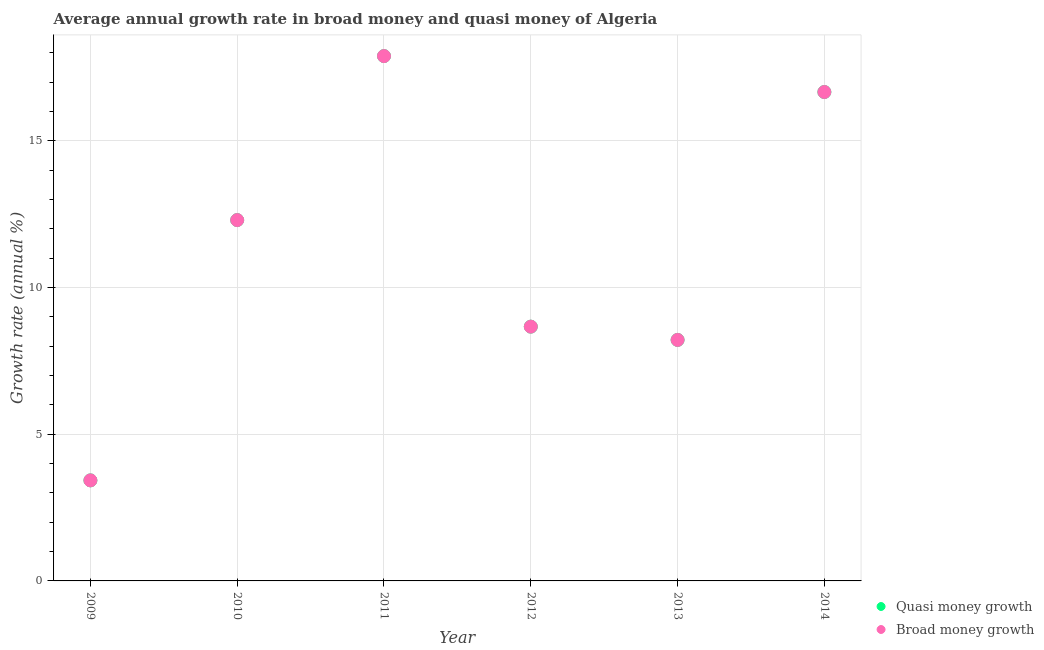Is the number of dotlines equal to the number of legend labels?
Provide a succinct answer. Yes. What is the annual growth rate in quasi money in 2014?
Your answer should be compact. 16.67. Across all years, what is the maximum annual growth rate in broad money?
Your response must be concise. 17.89. Across all years, what is the minimum annual growth rate in broad money?
Offer a terse response. 3.43. What is the total annual growth rate in broad money in the graph?
Keep it short and to the point. 67.17. What is the difference between the annual growth rate in quasi money in 2010 and that in 2012?
Your answer should be compact. 3.63. What is the difference between the annual growth rate in quasi money in 2011 and the annual growth rate in broad money in 2014?
Give a very brief answer. 1.22. What is the average annual growth rate in broad money per year?
Give a very brief answer. 11.19. In how many years, is the annual growth rate in broad money greater than 9 %?
Keep it short and to the point. 3. What is the ratio of the annual growth rate in quasi money in 2012 to that in 2013?
Your answer should be compact. 1.06. What is the difference between the highest and the second highest annual growth rate in quasi money?
Offer a terse response. 1.22. What is the difference between the highest and the lowest annual growth rate in broad money?
Provide a short and direct response. 14.46. Does the annual growth rate in broad money monotonically increase over the years?
Make the answer very short. No. How many dotlines are there?
Offer a terse response. 2. How many years are there in the graph?
Give a very brief answer. 6. What is the difference between two consecutive major ticks on the Y-axis?
Your answer should be compact. 5. Are the values on the major ticks of Y-axis written in scientific E-notation?
Provide a short and direct response. No. Does the graph contain grids?
Offer a terse response. Yes. Where does the legend appear in the graph?
Give a very brief answer. Bottom right. How many legend labels are there?
Offer a very short reply. 2. How are the legend labels stacked?
Provide a short and direct response. Vertical. What is the title of the graph?
Keep it short and to the point. Average annual growth rate in broad money and quasi money of Algeria. What is the label or title of the Y-axis?
Your answer should be very brief. Growth rate (annual %). What is the Growth rate (annual %) of Quasi money growth in 2009?
Make the answer very short. 3.43. What is the Growth rate (annual %) of Broad money growth in 2009?
Make the answer very short. 3.43. What is the Growth rate (annual %) in Quasi money growth in 2010?
Offer a very short reply. 12.3. What is the Growth rate (annual %) in Broad money growth in 2010?
Your response must be concise. 12.3. What is the Growth rate (annual %) of Quasi money growth in 2011?
Keep it short and to the point. 17.89. What is the Growth rate (annual %) of Broad money growth in 2011?
Offer a very short reply. 17.89. What is the Growth rate (annual %) in Quasi money growth in 2012?
Your answer should be compact. 8.67. What is the Growth rate (annual %) in Broad money growth in 2012?
Make the answer very short. 8.67. What is the Growth rate (annual %) in Quasi money growth in 2013?
Your answer should be very brief. 8.22. What is the Growth rate (annual %) of Broad money growth in 2013?
Your answer should be compact. 8.22. What is the Growth rate (annual %) in Quasi money growth in 2014?
Your answer should be compact. 16.67. What is the Growth rate (annual %) in Broad money growth in 2014?
Keep it short and to the point. 16.67. Across all years, what is the maximum Growth rate (annual %) in Quasi money growth?
Make the answer very short. 17.89. Across all years, what is the maximum Growth rate (annual %) of Broad money growth?
Offer a terse response. 17.89. Across all years, what is the minimum Growth rate (annual %) of Quasi money growth?
Offer a terse response. 3.43. Across all years, what is the minimum Growth rate (annual %) in Broad money growth?
Offer a very short reply. 3.43. What is the total Growth rate (annual %) in Quasi money growth in the graph?
Keep it short and to the point. 67.17. What is the total Growth rate (annual %) of Broad money growth in the graph?
Ensure brevity in your answer.  67.17. What is the difference between the Growth rate (annual %) in Quasi money growth in 2009 and that in 2010?
Your answer should be very brief. -8.87. What is the difference between the Growth rate (annual %) in Broad money growth in 2009 and that in 2010?
Offer a very short reply. -8.87. What is the difference between the Growth rate (annual %) of Quasi money growth in 2009 and that in 2011?
Your response must be concise. -14.46. What is the difference between the Growth rate (annual %) in Broad money growth in 2009 and that in 2011?
Make the answer very short. -14.46. What is the difference between the Growth rate (annual %) in Quasi money growth in 2009 and that in 2012?
Ensure brevity in your answer.  -5.24. What is the difference between the Growth rate (annual %) of Broad money growth in 2009 and that in 2012?
Offer a terse response. -5.24. What is the difference between the Growth rate (annual %) in Quasi money growth in 2009 and that in 2013?
Offer a very short reply. -4.79. What is the difference between the Growth rate (annual %) in Broad money growth in 2009 and that in 2013?
Offer a terse response. -4.79. What is the difference between the Growth rate (annual %) in Quasi money growth in 2009 and that in 2014?
Provide a short and direct response. -13.24. What is the difference between the Growth rate (annual %) in Broad money growth in 2009 and that in 2014?
Your response must be concise. -13.24. What is the difference between the Growth rate (annual %) in Quasi money growth in 2010 and that in 2011?
Your response must be concise. -5.59. What is the difference between the Growth rate (annual %) in Broad money growth in 2010 and that in 2011?
Make the answer very short. -5.59. What is the difference between the Growth rate (annual %) of Quasi money growth in 2010 and that in 2012?
Keep it short and to the point. 3.63. What is the difference between the Growth rate (annual %) in Broad money growth in 2010 and that in 2012?
Provide a short and direct response. 3.63. What is the difference between the Growth rate (annual %) in Quasi money growth in 2010 and that in 2013?
Provide a succinct answer. 4.09. What is the difference between the Growth rate (annual %) in Broad money growth in 2010 and that in 2013?
Ensure brevity in your answer.  4.09. What is the difference between the Growth rate (annual %) in Quasi money growth in 2010 and that in 2014?
Your answer should be very brief. -4.37. What is the difference between the Growth rate (annual %) of Broad money growth in 2010 and that in 2014?
Ensure brevity in your answer.  -4.37. What is the difference between the Growth rate (annual %) in Quasi money growth in 2011 and that in 2012?
Offer a very short reply. 9.22. What is the difference between the Growth rate (annual %) in Broad money growth in 2011 and that in 2012?
Keep it short and to the point. 9.22. What is the difference between the Growth rate (annual %) of Quasi money growth in 2011 and that in 2013?
Make the answer very short. 9.68. What is the difference between the Growth rate (annual %) of Broad money growth in 2011 and that in 2013?
Keep it short and to the point. 9.68. What is the difference between the Growth rate (annual %) in Quasi money growth in 2011 and that in 2014?
Your response must be concise. 1.22. What is the difference between the Growth rate (annual %) in Broad money growth in 2011 and that in 2014?
Give a very brief answer. 1.22. What is the difference between the Growth rate (annual %) in Quasi money growth in 2012 and that in 2013?
Your answer should be compact. 0.45. What is the difference between the Growth rate (annual %) of Broad money growth in 2012 and that in 2013?
Give a very brief answer. 0.45. What is the difference between the Growth rate (annual %) in Quasi money growth in 2012 and that in 2014?
Provide a succinct answer. -8. What is the difference between the Growth rate (annual %) of Broad money growth in 2012 and that in 2014?
Keep it short and to the point. -8. What is the difference between the Growth rate (annual %) in Quasi money growth in 2013 and that in 2014?
Provide a short and direct response. -8.45. What is the difference between the Growth rate (annual %) in Broad money growth in 2013 and that in 2014?
Provide a short and direct response. -8.45. What is the difference between the Growth rate (annual %) of Quasi money growth in 2009 and the Growth rate (annual %) of Broad money growth in 2010?
Make the answer very short. -8.87. What is the difference between the Growth rate (annual %) of Quasi money growth in 2009 and the Growth rate (annual %) of Broad money growth in 2011?
Your answer should be compact. -14.46. What is the difference between the Growth rate (annual %) in Quasi money growth in 2009 and the Growth rate (annual %) in Broad money growth in 2012?
Offer a very short reply. -5.24. What is the difference between the Growth rate (annual %) of Quasi money growth in 2009 and the Growth rate (annual %) of Broad money growth in 2013?
Provide a succinct answer. -4.79. What is the difference between the Growth rate (annual %) of Quasi money growth in 2009 and the Growth rate (annual %) of Broad money growth in 2014?
Offer a very short reply. -13.24. What is the difference between the Growth rate (annual %) of Quasi money growth in 2010 and the Growth rate (annual %) of Broad money growth in 2011?
Provide a short and direct response. -5.59. What is the difference between the Growth rate (annual %) of Quasi money growth in 2010 and the Growth rate (annual %) of Broad money growth in 2012?
Provide a short and direct response. 3.63. What is the difference between the Growth rate (annual %) in Quasi money growth in 2010 and the Growth rate (annual %) in Broad money growth in 2013?
Your answer should be compact. 4.09. What is the difference between the Growth rate (annual %) in Quasi money growth in 2010 and the Growth rate (annual %) in Broad money growth in 2014?
Your answer should be compact. -4.37. What is the difference between the Growth rate (annual %) of Quasi money growth in 2011 and the Growth rate (annual %) of Broad money growth in 2012?
Offer a very short reply. 9.22. What is the difference between the Growth rate (annual %) in Quasi money growth in 2011 and the Growth rate (annual %) in Broad money growth in 2013?
Keep it short and to the point. 9.68. What is the difference between the Growth rate (annual %) of Quasi money growth in 2011 and the Growth rate (annual %) of Broad money growth in 2014?
Your answer should be very brief. 1.22. What is the difference between the Growth rate (annual %) of Quasi money growth in 2012 and the Growth rate (annual %) of Broad money growth in 2013?
Provide a short and direct response. 0.45. What is the difference between the Growth rate (annual %) in Quasi money growth in 2012 and the Growth rate (annual %) in Broad money growth in 2014?
Your answer should be compact. -8. What is the difference between the Growth rate (annual %) of Quasi money growth in 2013 and the Growth rate (annual %) of Broad money growth in 2014?
Your answer should be very brief. -8.45. What is the average Growth rate (annual %) of Quasi money growth per year?
Your answer should be very brief. 11.19. What is the average Growth rate (annual %) of Broad money growth per year?
Your response must be concise. 11.19. In the year 2010, what is the difference between the Growth rate (annual %) of Quasi money growth and Growth rate (annual %) of Broad money growth?
Provide a short and direct response. 0. In the year 2012, what is the difference between the Growth rate (annual %) of Quasi money growth and Growth rate (annual %) of Broad money growth?
Your response must be concise. 0. In the year 2013, what is the difference between the Growth rate (annual %) of Quasi money growth and Growth rate (annual %) of Broad money growth?
Ensure brevity in your answer.  0. What is the ratio of the Growth rate (annual %) in Quasi money growth in 2009 to that in 2010?
Offer a terse response. 0.28. What is the ratio of the Growth rate (annual %) in Broad money growth in 2009 to that in 2010?
Ensure brevity in your answer.  0.28. What is the ratio of the Growth rate (annual %) of Quasi money growth in 2009 to that in 2011?
Provide a short and direct response. 0.19. What is the ratio of the Growth rate (annual %) in Broad money growth in 2009 to that in 2011?
Your response must be concise. 0.19. What is the ratio of the Growth rate (annual %) of Quasi money growth in 2009 to that in 2012?
Provide a short and direct response. 0.4. What is the ratio of the Growth rate (annual %) of Broad money growth in 2009 to that in 2012?
Offer a terse response. 0.4. What is the ratio of the Growth rate (annual %) in Quasi money growth in 2009 to that in 2013?
Ensure brevity in your answer.  0.42. What is the ratio of the Growth rate (annual %) of Broad money growth in 2009 to that in 2013?
Give a very brief answer. 0.42. What is the ratio of the Growth rate (annual %) of Quasi money growth in 2009 to that in 2014?
Give a very brief answer. 0.21. What is the ratio of the Growth rate (annual %) of Broad money growth in 2009 to that in 2014?
Your response must be concise. 0.21. What is the ratio of the Growth rate (annual %) in Quasi money growth in 2010 to that in 2011?
Offer a very short reply. 0.69. What is the ratio of the Growth rate (annual %) in Broad money growth in 2010 to that in 2011?
Make the answer very short. 0.69. What is the ratio of the Growth rate (annual %) of Quasi money growth in 2010 to that in 2012?
Provide a short and direct response. 1.42. What is the ratio of the Growth rate (annual %) in Broad money growth in 2010 to that in 2012?
Offer a terse response. 1.42. What is the ratio of the Growth rate (annual %) of Quasi money growth in 2010 to that in 2013?
Offer a terse response. 1.5. What is the ratio of the Growth rate (annual %) in Broad money growth in 2010 to that in 2013?
Ensure brevity in your answer.  1.5. What is the ratio of the Growth rate (annual %) in Quasi money growth in 2010 to that in 2014?
Offer a very short reply. 0.74. What is the ratio of the Growth rate (annual %) in Broad money growth in 2010 to that in 2014?
Offer a terse response. 0.74. What is the ratio of the Growth rate (annual %) of Quasi money growth in 2011 to that in 2012?
Keep it short and to the point. 2.06. What is the ratio of the Growth rate (annual %) of Broad money growth in 2011 to that in 2012?
Your answer should be very brief. 2.06. What is the ratio of the Growth rate (annual %) of Quasi money growth in 2011 to that in 2013?
Provide a succinct answer. 2.18. What is the ratio of the Growth rate (annual %) of Broad money growth in 2011 to that in 2013?
Offer a terse response. 2.18. What is the ratio of the Growth rate (annual %) of Quasi money growth in 2011 to that in 2014?
Keep it short and to the point. 1.07. What is the ratio of the Growth rate (annual %) in Broad money growth in 2011 to that in 2014?
Keep it short and to the point. 1.07. What is the ratio of the Growth rate (annual %) in Quasi money growth in 2012 to that in 2013?
Provide a short and direct response. 1.06. What is the ratio of the Growth rate (annual %) in Broad money growth in 2012 to that in 2013?
Ensure brevity in your answer.  1.06. What is the ratio of the Growth rate (annual %) in Quasi money growth in 2012 to that in 2014?
Provide a succinct answer. 0.52. What is the ratio of the Growth rate (annual %) in Broad money growth in 2012 to that in 2014?
Provide a short and direct response. 0.52. What is the ratio of the Growth rate (annual %) in Quasi money growth in 2013 to that in 2014?
Your answer should be very brief. 0.49. What is the ratio of the Growth rate (annual %) of Broad money growth in 2013 to that in 2014?
Keep it short and to the point. 0.49. What is the difference between the highest and the second highest Growth rate (annual %) of Quasi money growth?
Give a very brief answer. 1.22. What is the difference between the highest and the second highest Growth rate (annual %) of Broad money growth?
Give a very brief answer. 1.22. What is the difference between the highest and the lowest Growth rate (annual %) in Quasi money growth?
Offer a very short reply. 14.46. What is the difference between the highest and the lowest Growth rate (annual %) in Broad money growth?
Provide a short and direct response. 14.46. 